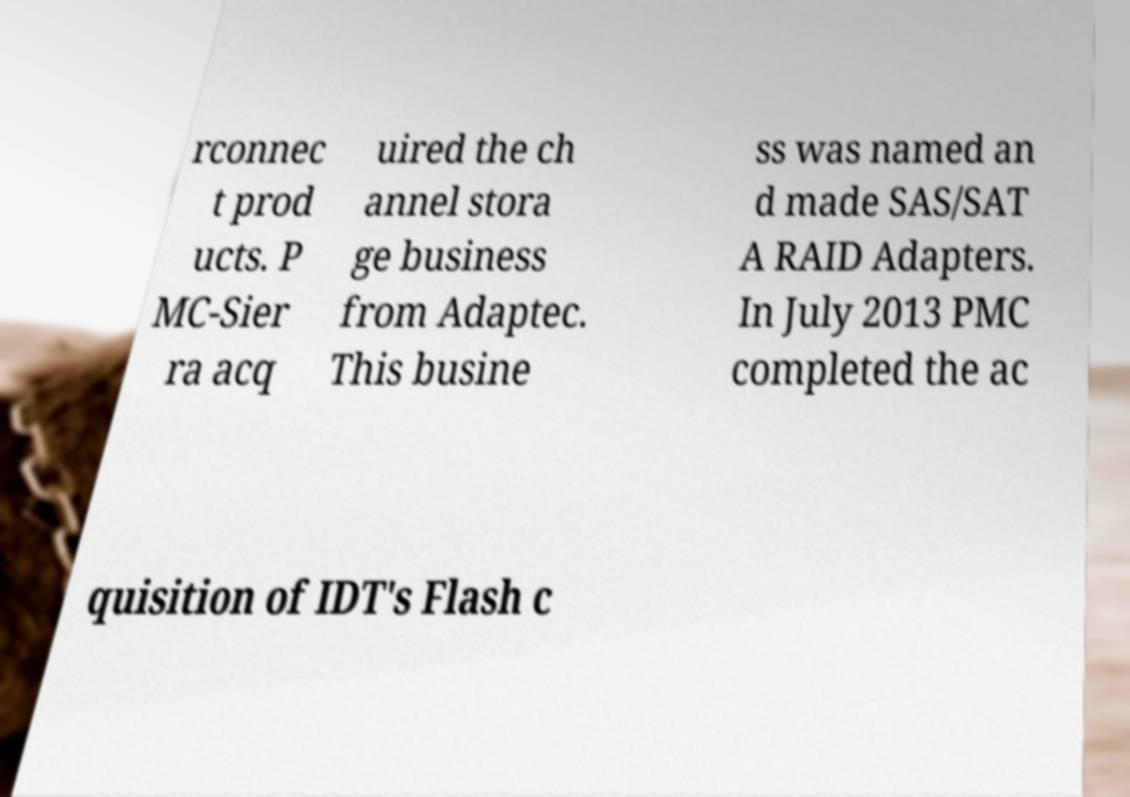Can you accurately transcribe the text from the provided image for me? rconnec t prod ucts. P MC-Sier ra acq uired the ch annel stora ge business from Adaptec. This busine ss was named an d made SAS/SAT A RAID Adapters. In July 2013 PMC completed the ac quisition of IDT's Flash c 